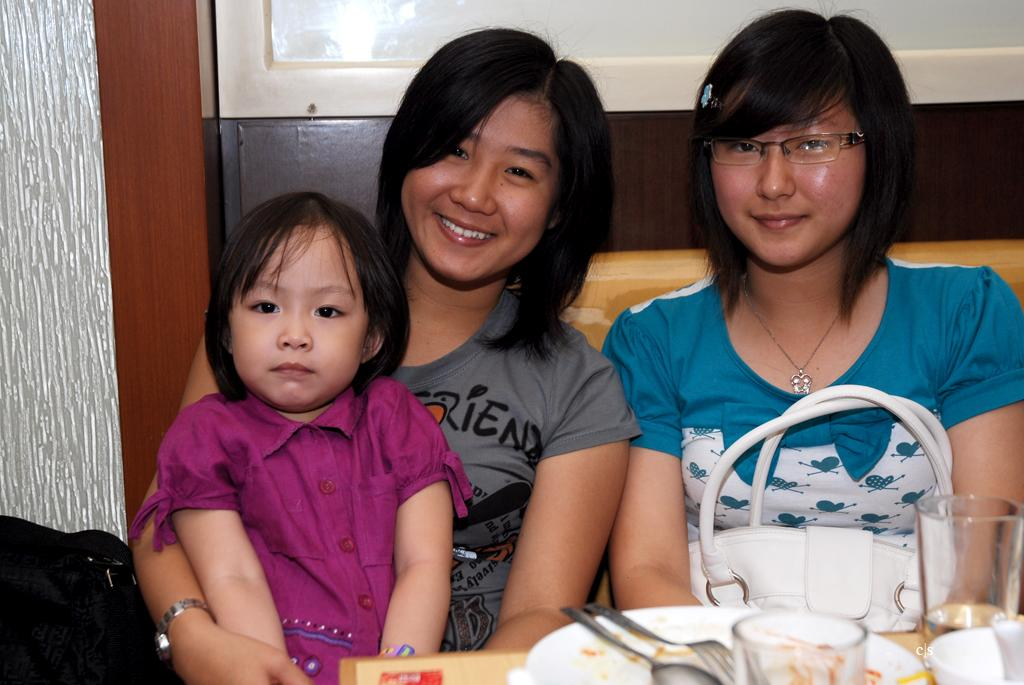How many women are in the image? There are two women in the image. What are the women doing in the image? The women are sitting and smiling. Is there a child with the women in the image? Yes, there is a girl sitting on one of the women. What items are present in front of the women? A plate, a fork, a spoon, a glass, and bags are present in front of the women. What type of fog can be seen in the image? There is no fog present in the image. How does the railway affect the scene in the image? There is no railway present in the image. 